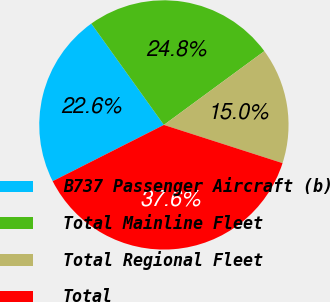Convert chart. <chart><loc_0><loc_0><loc_500><loc_500><pie_chart><fcel>B737 Passenger Aircraft (b)<fcel>Total Mainline Fleet<fcel>Total Regional Fleet<fcel>Total<nl><fcel>22.56%<fcel>24.81%<fcel>15.04%<fcel>37.59%<nl></chart> 